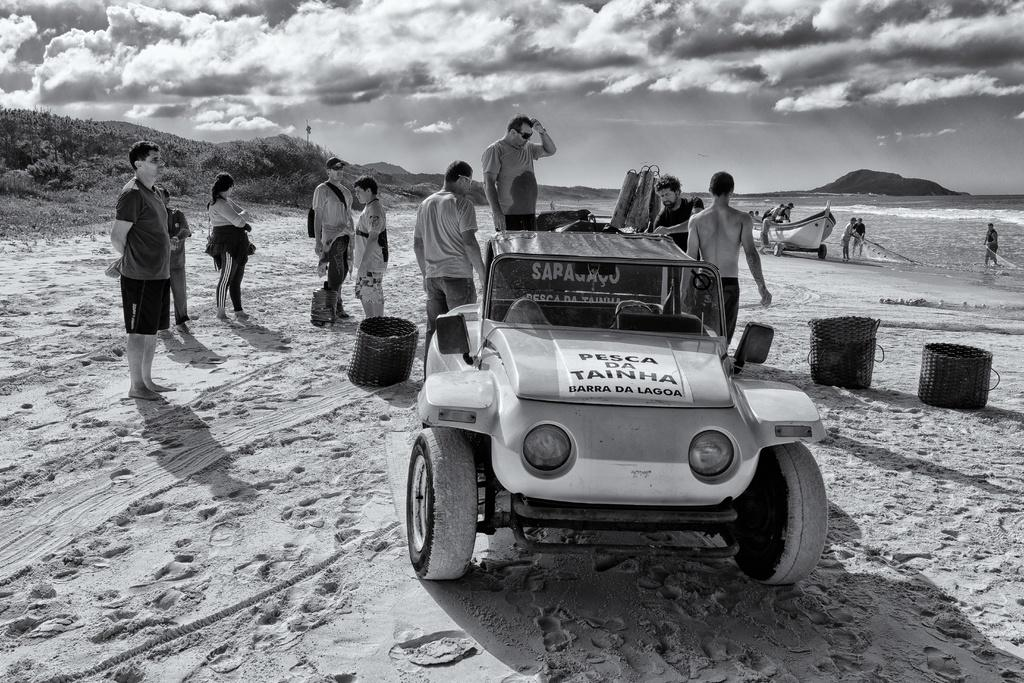How many people can be seen in the image? There are persons standing in the image. What is the primary setting of the image? There is water visible in the image, suggesting a waterfront or beach setting. What type of watercraft is present in the image? There is a boat in the image. What other mode of transportation can be seen in the image? There is a vehicle on the sand in the image. What can be seen in the background of the image? There are trees and the sky visible in the background of the image. What is the weather like in the image? Clouds are present in the sky, indicating that it might be partly cloudy. Can you see a monkey wearing a veil in the image? There is no monkey or veil present in the image. Is there a jail visible in the image? There is no jail present in the image. 